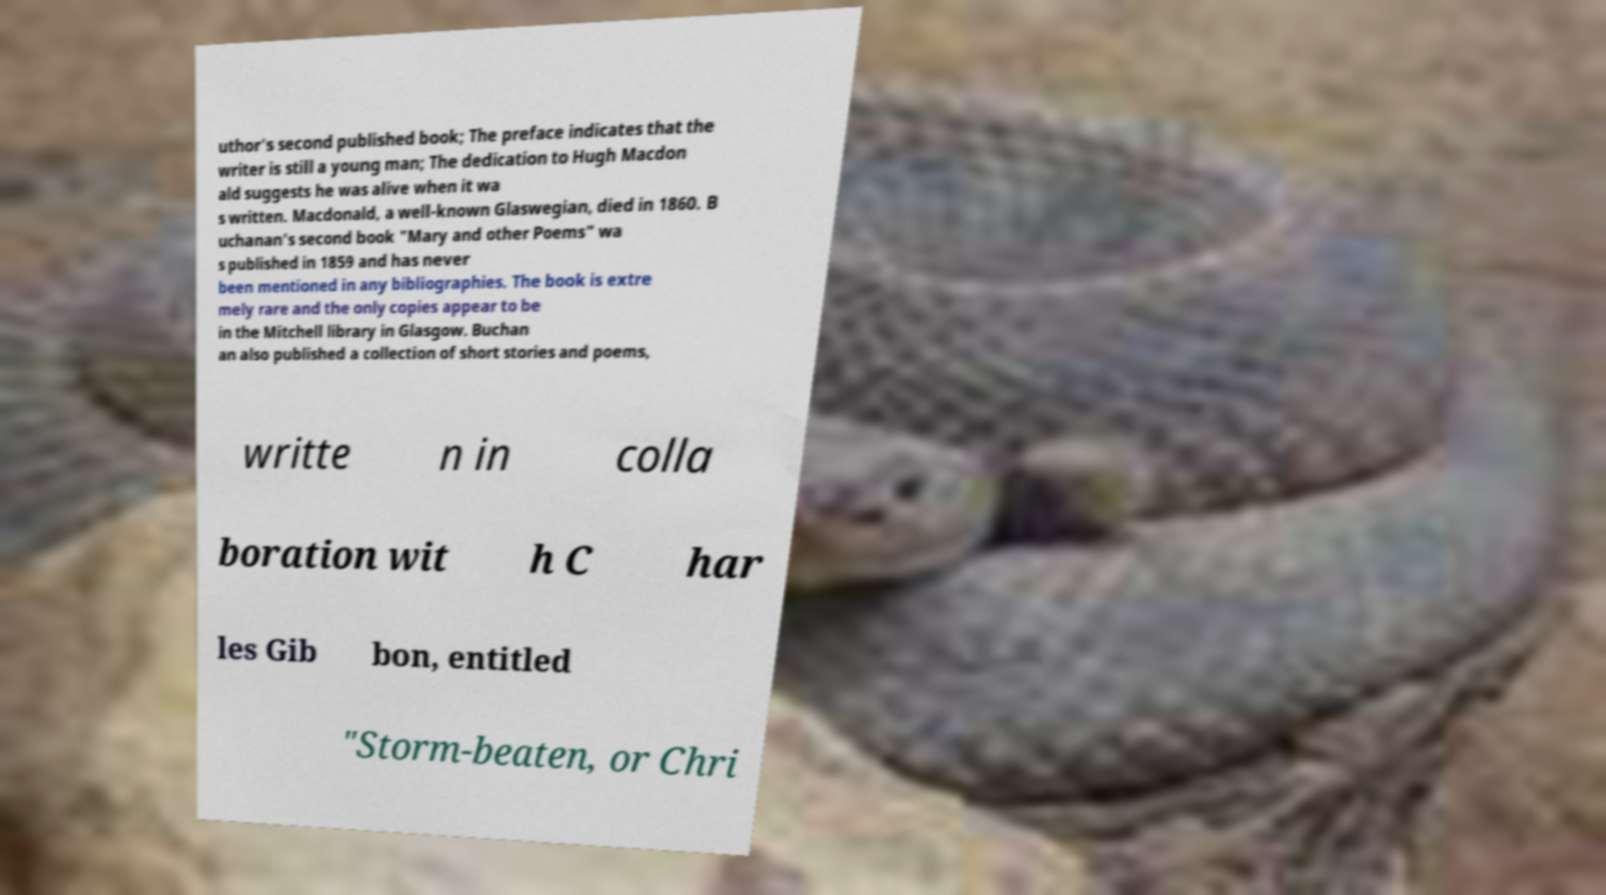Could you assist in decoding the text presented in this image and type it out clearly? uthor's second published book; The preface indicates that the writer is still a young man; The dedication to Hugh Macdon ald suggests he was alive when it wa s written. Macdonald, a well-known Glaswegian, died in 1860. B uchanan's second book "Mary and other Poems" wa s published in 1859 and has never been mentioned in any bibliographies. The book is extre mely rare and the only copies appear to be in the Mitchell library in Glasgow. Buchan an also published a collection of short stories and poems, writte n in colla boration wit h C har les Gib bon, entitled "Storm-beaten, or Chri 